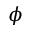<formula> <loc_0><loc_0><loc_500><loc_500>\phi</formula> 